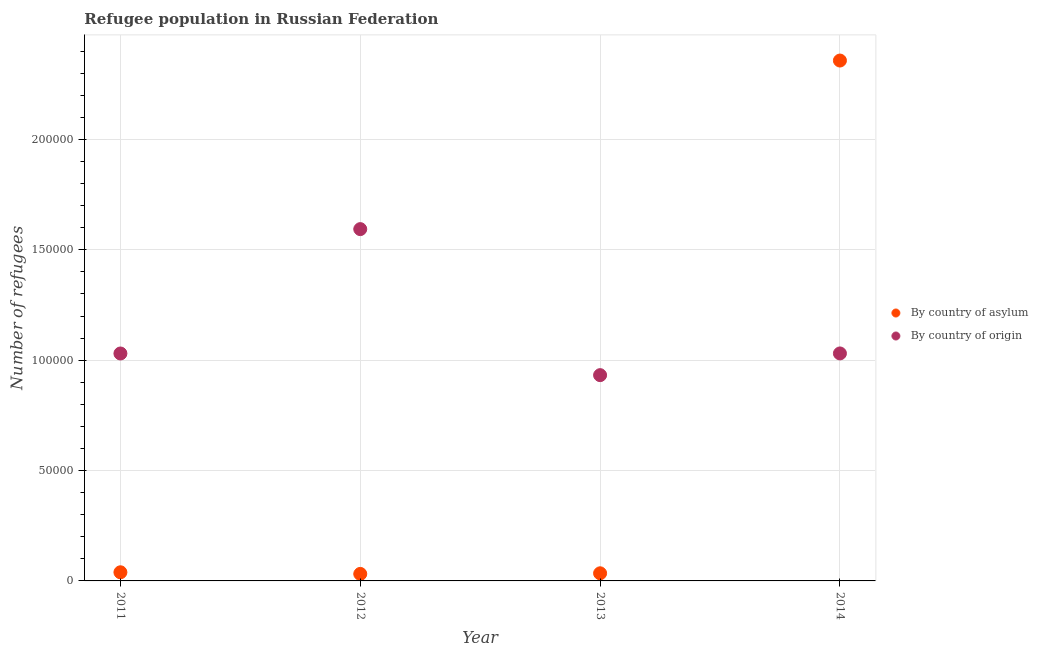How many different coloured dotlines are there?
Ensure brevity in your answer.  2. Is the number of dotlines equal to the number of legend labels?
Provide a short and direct response. Yes. What is the number of refugees by country of origin in 2014?
Ensure brevity in your answer.  1.03e+05. Across all years, what is the maximum number of refugees by country of asylum?
Offer a very short reply. 2.36e+05. Across all years, what is the minimum number of refugees by country of origin?
Ensure brevity in your answer.  9.32e+04. What is the total number of refugees by country of asylum in the graph?
Your response must be concise. 2.46e+05. What is the difference between the number of refugees by country of origin in 2011 and that in 2012?
Provide a succinct answer. -5.63e+04. What is the difference between the number of refugees by country of asylum in 2013 and the number of refugees by country of origin in 2012?
Make the answer very short. -1.56e+05. What is the average number of refugees by country of asylum per year?
Your answer should be very brief. 6.16e+04. In the year 2012, what is the difference between the number of refugees by country of origin and number of refugees by country of asylum?
Offer a very short reply. 1.56e+05. What is the ratio of the number of refugees by country of origin in 2011 to that in 2013?
Provide a succinct answer. 1.11. Is the difference between the number of refugees by country of asylum in 2012 and 2013 greater than the difference between the number of refugees by country of origin in 2012 and 2013?
Give a very brief answer. No. What is the difference between the highest and the second highest number of refugees by country of asylum?
Your answer should be compact. 2.32e+05. What is the difference between the highest and the lowest number of refugees by country of origin?
Give a very brief answer. 6.62e+04. In how many years, is the number of refugees by country of origin greater than the average number of refugees by country of origin taken over all years?
Make the answer very short. 1. Does the number of refugees by country of origin monotonically increase over the years?
Make the answer very short. No. Is the number of refugees by country of origin strictly less than the number of refugees by country of asylum over the years?
Your answer should be very brief. No. How many dotlines are there?
Make the answer very short. 2. How many years are there in the graph?
Provide a succinct answer. 4. What is the difference between two consecutive major ticks on the Y-axis?
Provide a short and direct response. 5.00e+04. Does the graph contain any zero values?
Offer a terse response. No. Does the graph contain grids?
Ensure brevity in your answer.  Yes. Where does the legend appear in the graph?
Provide a succinct answer. Center right. What is the title of the graph?
Your answer should be compact. Refugee population in Russian Federation. What is the label or title of the Y-axis?
Give a very brief answer. Number of refugees. What is the Number of refugees in By country of asylum in 2011?
Offer a very short reply. 3914. What is the Number of refugees in By country of origin in 2011?
Your response must be concise. 1.03e+05. What is the Number of refugees in By country of asylum in 2012?
Provide a short and direct response. 3178. What is the Number of refugees of By country of origin in 2012?
Your response must be concise. 1.59e+05. What is the Number of refugees of By country of asylum in 2013?
Offer a very short reply. 3458. What is the Number of refugees of By country of origin in 2013?
Give a very brief answer. 9.32e+04. What is the Number of refugees in By country of asylum in 2014?
Provide a succinct answer. 2.36e+05. What is the Number of refugees in By country of origin in 2014?
Your response must be concise. 1.03e+05. Across all years, what is the maximum Number of refugees of By country of asylum?
Provide a short and direct response. 2.36e+05. Across all years, what is the maximum Number of refugees of By country of origin?
Make the answer very short. 1.59e+05. Across all years, what is the minimum Number of refugees of By country of asylum?
Your answer should be compact. 3178. Across all years, what is the minimum Number of refugees in By country of origin?
Your answer should be very brief. 9.32e+04. What is the total Number of refugees in By country of asylum in the graph?
Ensure brevity in your answer.  2.46e+05. What is the total Number of refugees in By country of origin in the graph?
Make the answer very short. 4.59e+05. What is the difference between the Number of refugees in By country of asylum in 2011 and that in 2012?
Your answer should be very brief. 736. What is the difference between the Number of refugees in By country of origin in 2011 and that in 2012?
Ensure brevity in your answer.  -5.63e+04. What is the difference between the Number of refugees in By country of asylum in 2011 and that in 2013?
Ensure brevity in your answer.  456. What is the difference between the Number of refugees of By country of origin in 2011 and that in 2013?
Provide a short and direct response. 9813. What is the difference between the Number of refugees in By country of asylum in 2011 and that in 2014?
Provide a short and direct response. -2.32e+05. What is the difference between the Number of refugees of By country of origin in 2011 and that in 2014?
Your answer should be very brief. -24. What is the difference between the Number of refugees of By country of asylum in 2012 and that in 2013?
Give a very brief answer. -280. What is the difference between the Number of refugees in By country of origin in 2012 and that in 2013?
Ensure brevity in your answer.  6.62e+04. What is the difference between the Number of refugees of By country of asylum in 2012 and that in 2014?
Ensure brevity in your answer.  -2.33e+05. What is the difference between the Number of refugees in By country of origin in 2012 and that in 2014?
Make the answer very short. 5.63e+04. What is the difference between the Number of refugees in By country of asylum in 2013 and that in 2014?
Make the answer very short. -2.32e+05. What is the difference between the Number of refugees in By country of origin in 2013 and that in 2014?
Give a very brief answer. -9837. What is the difference between the Number of refugees in By country of asylum in 2011 and the Number of refugees in By country of origin in 2012?
Your answer should be compact. -1.55e+05. What is the difference between the Number of refugees in By country of asylum in 2011 and the Number of refugees in By country of origin in 2013?
Offer a terse response. -8.93e+04. What is the difference between the Number of refugees of By country of asylum in 2011 and the Number of refugees of By country of origin in 2014?
Ensure brevity in your answer.  -9.91e+04. What is the difference between the Number of refugees in By country of asylum in 2012 and the Number of refugees in By country of origin in 2013?
Provide a short and direct response. -9.00e+04. What is the difference between the Number of refugees in By country of asylum in 2012 and the Number of refugees in By country of origin in 2014?
Provide a succinct answer. -9.99e+04. What is the difference between the Number of refugees in By country of asylum in 2013 and the Number of refugees in By country of origin in 2014?
Provide a succinct answer. -9.96e+04. What is the average Number of refugees in By country of asylum per year?
Your answer should be very brief. 6.16e+04. What is the average Number of refugees of By country of origin per year?
Provide a succinct answer. 1.15e+05. In the year 2011, what is the difference between the Number of refugees of By country of asylum and Number of refugees of By country of origin?
Offer a very short reply. -9.91e+04. In the year 2012, what is the difference between the Number of refugees in By country of asylum and Number of refugees in By country of origin?
Offer a terse response. -1.56e+05. In the year 2013, what is the difference between the Number of refugees of By country of asylum and Number of refugees of By country of origin?
Offer a very short reply. -8.98e+04. In the year 2014, what is the difference between the Number of refugees of By country of asylum and Number of refugees of By country of origin?
Your answer should be very brief. 1.33e+05. What is the ratio of the Number of refugees of By country of asylum in 2011 to that in 2012?
Keep it short and to the point. 1.23. What is the ratio of the Number of refugees of By country of origin in 2011 to that in 2012?
Offer a terse response. 0.65. What is the ratio of the Number of refugees of By country of asylum in 2011 to that in 2013?
Ensure brevity in your answer.  1.13. What is the ratio of the Number of refugees in By country of origin in 2011 to that in 2013?
Keep it short and to the point. 1.11. What is the ratio of the Number of refugees of By country of asylum in 2011 to that in 2014?
Your response must be concise. 0.02. What is the ratio of the Number of refugees of By country of origin in 2011 to that in 2014?
Provide a short and direct response. 1. What is the ratio of the Number of refugees of By country of asylum in 2012 to that in 2013?
Your response must be concise. 0.92. What is the ratio of the Number of refugees in By country of origin in 2012 to that in 2013?
Your answer should be very brief. 1.71. What is the ratio of the Number of refugees of By country of asylum in 2012 to that in 2014?
Your answer should be very brief. 0.01. What is the ratio of the Number of refugees of By country of origin in 2012 to that in 2014?
Offer a very short reply. 1.55. What is the ratio of the Number of refugees in By country of asylum in 2013 to that in 2014?
Provide a short and direct response. 0.01. What is the ratio of the Number of refugees in By country of origin in 2013 to that in 2014?
Offer a terse response. 0.9. What is the difference between the highest and the second highest Number of refugees of By country of asylum?
Give a very brief answer. 2.32e+05. What is the difference between the highest and the second highest Number of refugees in By country of origin?
Make the answer very short. 5.63e+04. What is the difference between the highest and the lowest Number of refugees of By country of asylum?
Ensure brevity in your answer.  2.33e+05. What is the difference between the highest and the lowest Number of refugees in By country of origin?
Keep it short and to the point. 6.62e+04. 